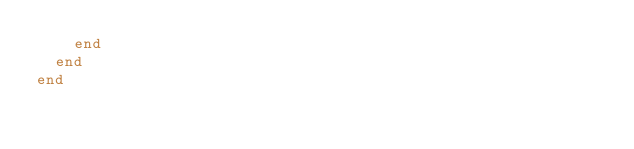Convert code to text. <code><loc_0><loc_0><loc_500><loc_500><_Ruby_>    end
  end
end
</code> 